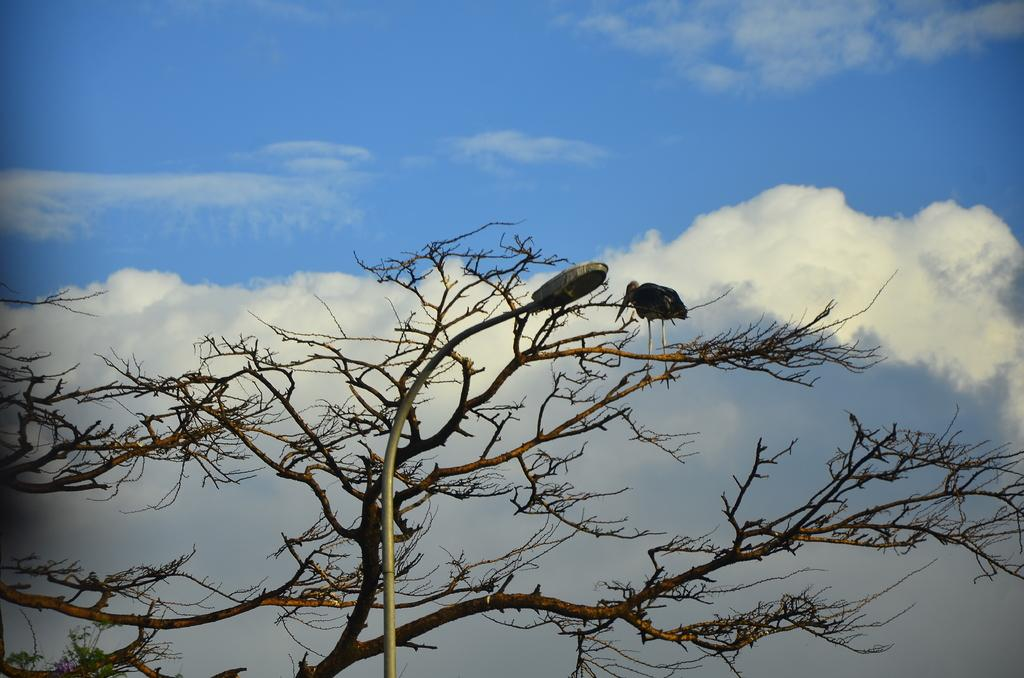What type of animal can be seen in the image? There is a bird in the image. Where is the bird located? The bird is on a tree. What other object is present in the image? There is a pole light in the image. How would you describe the sky in the image? The sky is blue and cloudy. What word is being used to describe the smoke in the image? There is no smoke present in the image, so there is no word being used to describe it. 